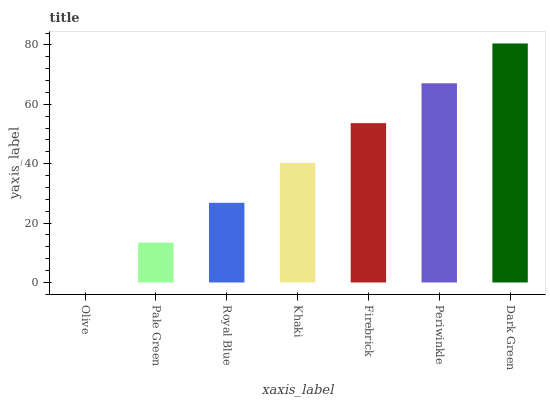Is Olive the minimum?
Answer yes or no. Yes. Is Dark Green the maximum?
Answer yes or no. Yes. Is Pale Green the minimum?
Answer yes or no. No. Is Pale Green the maximum?
Answer yes or no. No. Is Pale Green greater than Olive?
Answer yes or no. Yes. Is Olive less than Pale Green?
Answer yes or no. Yes. Is Olive greater than Pale Green?
Answer yes or no. No. Is Pale Green less than Olive?
Answer yes or no. No. Is Khaki the high median?
Answer yes or no. Yes. Is Khaki the low median?
Answer yes or no. Yes. Is Periwinkle the high median?
Answer yes or no. No. Is Olive the low median?
Answer yes or no. No. 